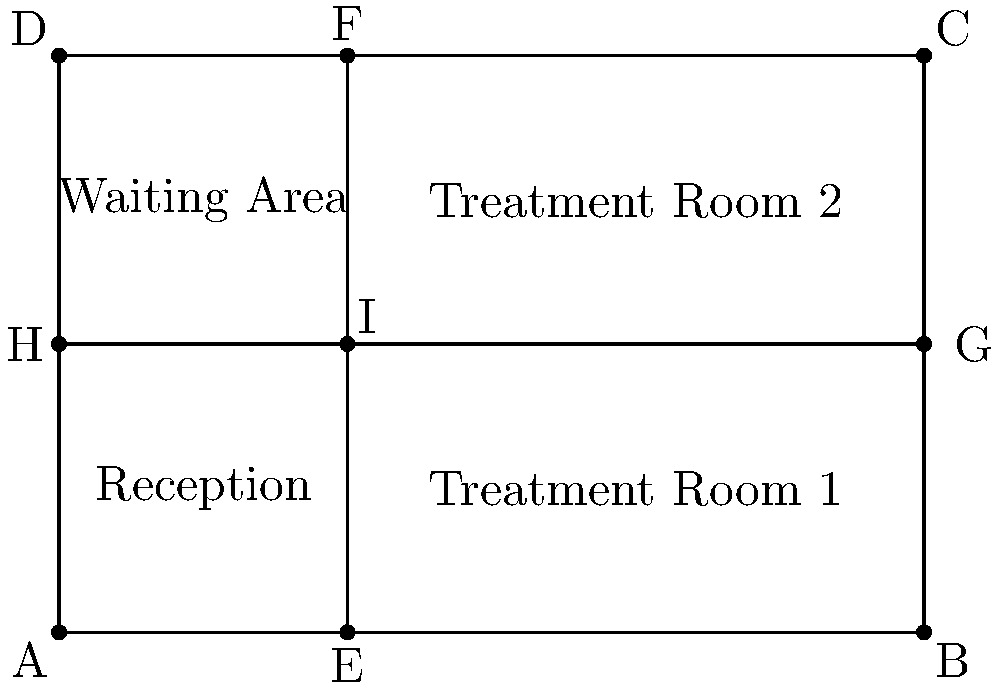In the clinic layout shown above, two perpendicular hallways intersect at point I. The clinic has a width of 6 meters and a length of 4 meters. If the vertical hallway is 2 meters from the left wall, what are the coordinates of point I? To find the coordinates of point I, we need to determine its position on both the x and y axes:

1. X-coordinate:
   - The vertical hallway is 2 meters from the left wall.
   - Therefore, the x-coordinate of point I is 2.

2. Y-coordinate:
   - The horizontal hallway divides the clinic's length equally.
   - The clinic's length is 4 meters.
   - So, the y-coordinate of point I is 4 ÷ 2 = 2.

3. Combining the x and y coordinates:
   - The coordinates of point I are (2, 2).

We can verify this by observing that:
- Point I is on the vertical line EF, which is 2 meters from the left wall.
- Point I is also on the horizontal line GH, which is halfway between the top and bottom walls.

Therefore, the intersection point I has coordinates (2, 2).
Answer: $(2, 2)$ 